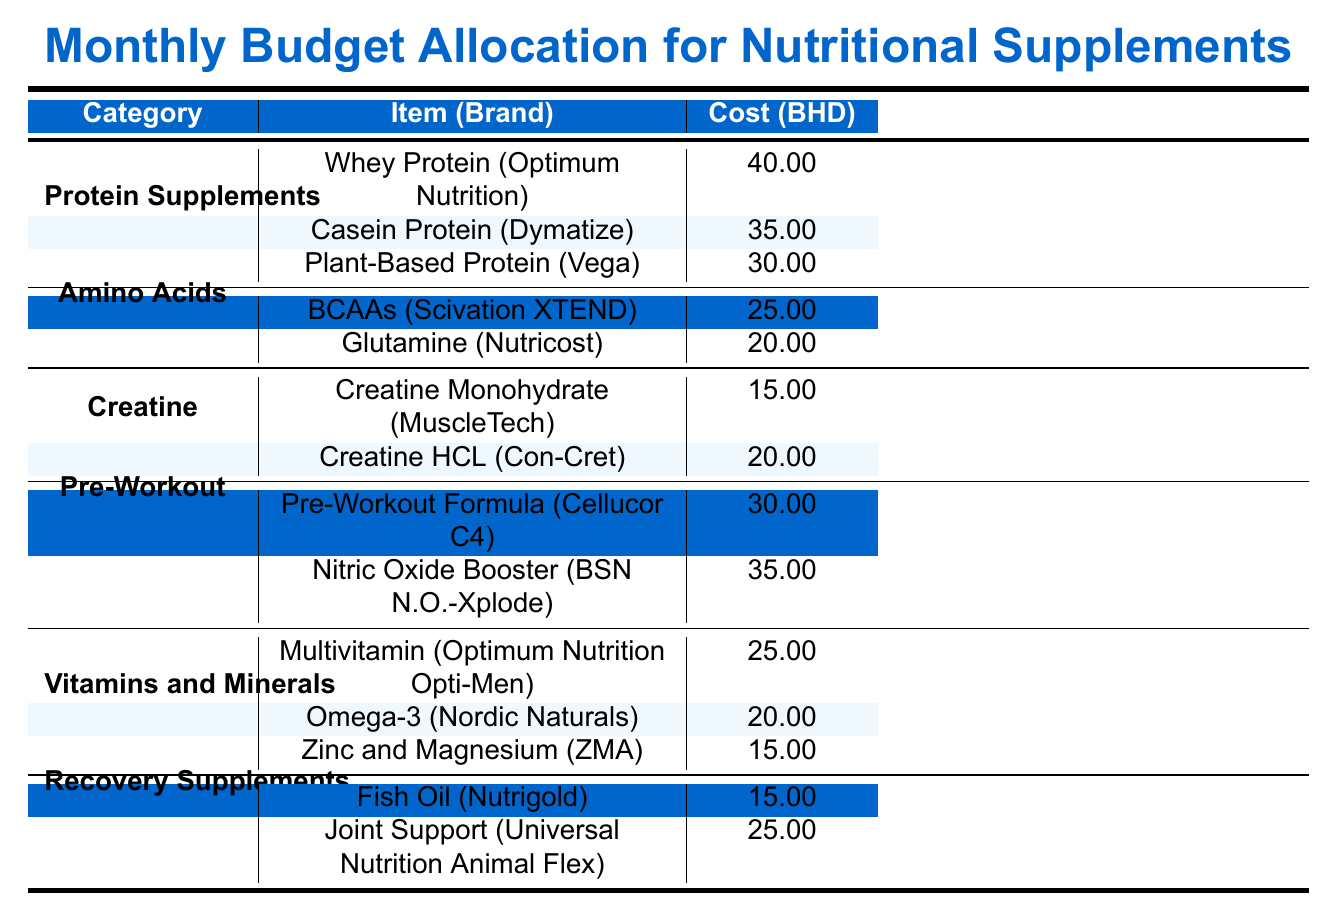What is the cost of Whey Protein from Optimum Nutrition? According to the table, the cost of Whey Protein (Optimum Nutrition) is listed in the Protein Supplements category under the item name. It is specified directly in the cost column.
Answer: 40.00 Which amino acid supplement is cheaper, BCAAs or Glutamine? Comparing the costs listed under the Amino Acids category, BCAAs (Scivation XTEND) costs 25.00, while Glutamine (Nutricost) costs 20.00. Glutamine is cheaper as 20.00 is less than 25.00.
Answer: Glutamine What is the total cost of all the vitamins and minerals supplements? The costs of the vitamins and minerals supplements as per the table are: Multivitamin (25.00), Omega-3 (20.00), and Zinc and Magnesium (15.00). Adding these together gives 25.00 + 20.00 + 15.00 = 60.00.
Answer: 60.00 Is the cost of Nitric Oxide Booster greater than the average cost of all Recovery Supplements? The costs of Recovery Supplements are Fish Oil (15.00) and Joint Support (25.00). The average cost can be calculated by summing both values (15.00 + 25.00 = 40.00) and dividing by 2, which gives 20.00. Since Nitric Oxide Booster costs 35.00, which is greater than 20.00, the answer is yes.
Answer: Yes How does the total allocation for Protein Supplements compare to that of Pre-Workout? The total cost for Protein Supplements is 40.00 (Whey Protein) + 35.00 (Casein Protein) + 30.00 (Plant-Based Protein) = 105.00. For Pre-Workout, it is 30.00 (Pre-Workout Formula) + 35.00 (Nitric Oxide Booster) = 65.00. Since 105.00 is greater than 65.00, Protein Supplements allocate more.
Answer: Protein Supplements have a higher allocation What is the only Creatine supplement that costs less than 20.00? The table indicates that under the Creatine category, we have Creatine Monohydrate (15.00) and Creatine HCL (20.00). Since only Creatine Monohydrate has a cost less than 20.00, it is the only one that fits this criterion.
Answer: Creatine Monohydrate Are there more items in the Vitamins and Minerals category than the Creatine category? The Vitamins and Minerals category has three items: Multivitamin, Omega-3, and Zinc and Magnesium, while the Creatine category has only two items: Creatine Monohydrate and Creatine HCL. Therefore, there are indeed more items in the Vitamins and Minerals category.
Answer: Yes What is the difference in cost between the most expensive and least expensive supplements? The most expensive supplement is Whey Protein at 40.00, and the least expensive is Creatine Monohydrate at 15.00. The difference can be calculated as 40.00 - 15.00 = 25.00.
Answer: 25.00 